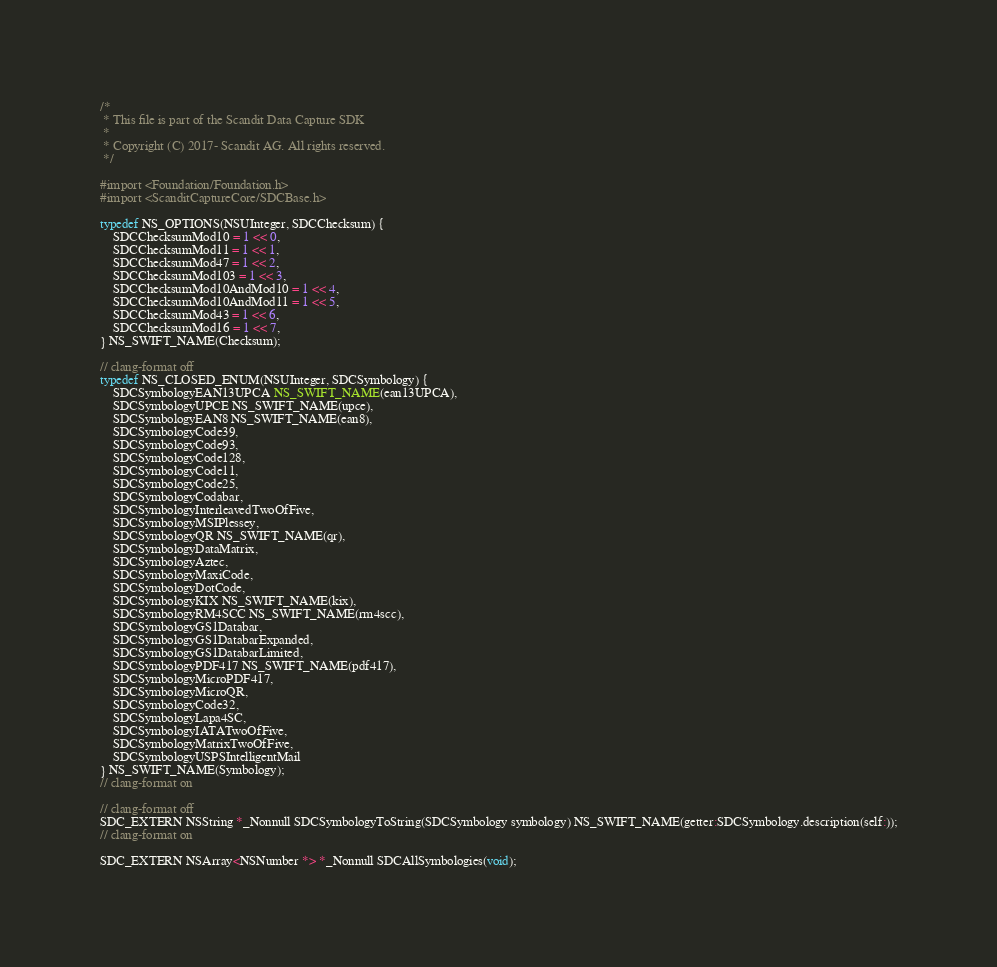Convert code to text. <code><loc_0><loc_0><loc_500><loc_500><_C_>/*
 * This file is part of the Scandit Data Capture SDK
 *
 * Copyright (C) 2017- Scandit AG. All rights reserved.
 */

#import <Foundation/Foundation.h>
#import <ScanditCaptureCore/SDCBase.h>

typedef NS_OPTIONS(NSUInteger, SDCChecksum) {
    SDCChecksumMod10 = 1 << 0,
    SDCChecksumMod11 = 1 << 1,
    SDCChecksumMod47 = 1 << 2,
    SDCChecksumMod103 = 1 << 3,
    SDCChecksumMod10AndMod10 = 1 << 4,
    SDCChecksumMod10AndMod11 = 1 << 5,
    SDCChecksumMod43 = 1 << 6,
    SDCChecksumMod16 = 1 << 7,
} NS_SWIFT_NAME(Checksum);

// clang-format off
typedef NS_CLOSED_ENUM(NSUInteger, SDCSymbology) {
    SDCSymbologyEAN13UPCA NS_SWIFT_NAME(ean13UPCA),
    SDCSymbologyUPCE NS_SWIFT_NAME(upce),
    SDCSymbologyEAN8 NS_SWIFT_NAME(ean8),
    SDCSymbologyCode39,
    SDCSymbologyCode93,
    SDCSymbologyCode128,
    SDCSymbologyCode11,
    SDCSymbologyCode25,
    SDCSymbologyCodabar,
    SDCSymbologyInterleavedTwoOfFive,
    SDCSymbologyMSIPlessey,
    SDCSymbologyQR NS_SWIFT_NAME(qr),
    SDCSymbologyDataMatrix,
    SDCSymbologyAztec,
    SDCSymbologyMaxiCode,
    SDCSymbologyDotCode,
    SDCSymbologyKIX NS_SWIFT_NAME(kix),
    SDCSymbologyRM4SCC NS_SWIFT_NAME(rm4scc),
    SDCSymbologyGS1Databar,
    SDCSymbologyGS1DatabarExpanded,
    SDCSymbologyGS1DatabarLimited,
    SDCSymbologyPDF417 NS_SWIFT_NAME(pdf417),
    SDCSymbologyMicroPDF417,
    SDCSymbologyMicroQR,
    SDCSymbologyCode32,
    SDCSymbologyLapa4SC,
    SDCSymbologyIATATwoOfFive,
    SDCSymbologyMatrixTwoOfFive,
    SDCSymbologyUSPSIntelligentMail
} NS_SWIFT_NAME(Symbology);
// clang-format on

// clang-format off
SDC_EXTERN NSString *_Nonnull SDCSymbologyToString(SDCSymbology symbology) NS_SWIFT_NAME(getter:SDCSymbology.description(self:));
// clang-format on

SDC_EXTERN NSArray<NSNumber *> *_Nonnull SDCAllSymbologies(void);
</code> 